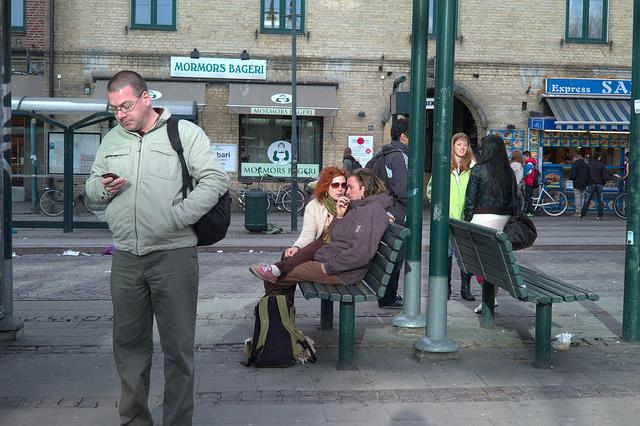What type of shop is the one with the woman's picture in a circle on the window? bakery 